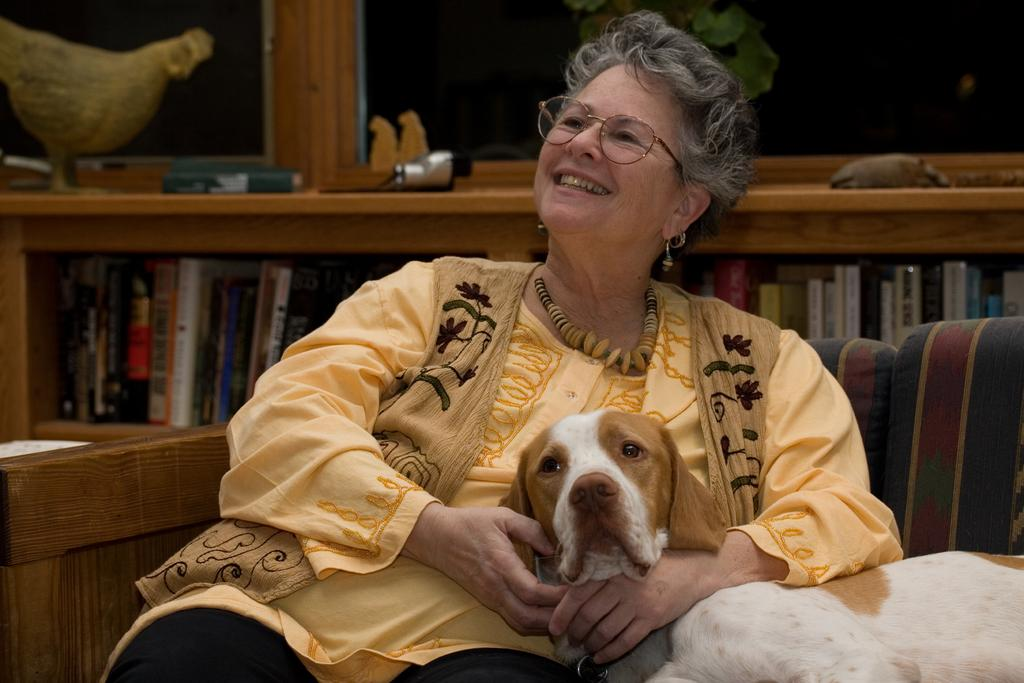What is the woman doing in the image? The woman is sitting on a wooden sofa and holding a dog. Can you describe the dog in the image? The dog looks pretty good. What other furniture is visible in the image? There is a bookshelf in the image. Is there any other animal present in the image? Yes, there is a hen in the left corner of the image. Where is the snake hiding in the image? There is no snake present in the image. What type of basin is used for washing hands in the image? There is no basin visible in the image. 